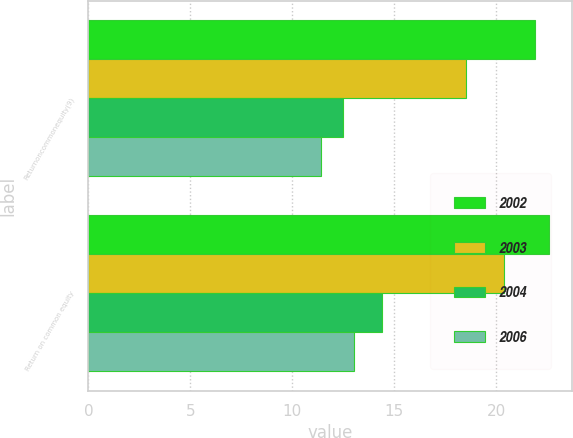Convert chart to OTSL. <chart><loc_0><loc_0><loc_500><loc_500><stacked_bar_chart><ecel><fcel>Returnoncommonequity(9)<fcel>Return on common equity<nl><fcel>2002<fcel>21.9<fcel>22.6<nl><fcel>2003<fcel>18.5<fcel>20.4<nl><fcel>2004<fcel>12.5<fcel>14.4<nl><fcel>2006<fcel>11.4<fcel>13<nl></chart> 